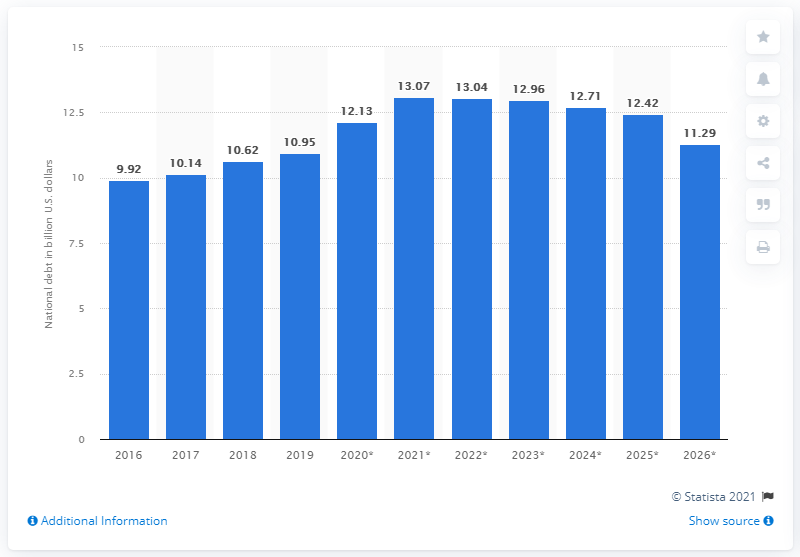Specify some key components in this picture. In 2019, the national debt of Gabon was 10.95. 